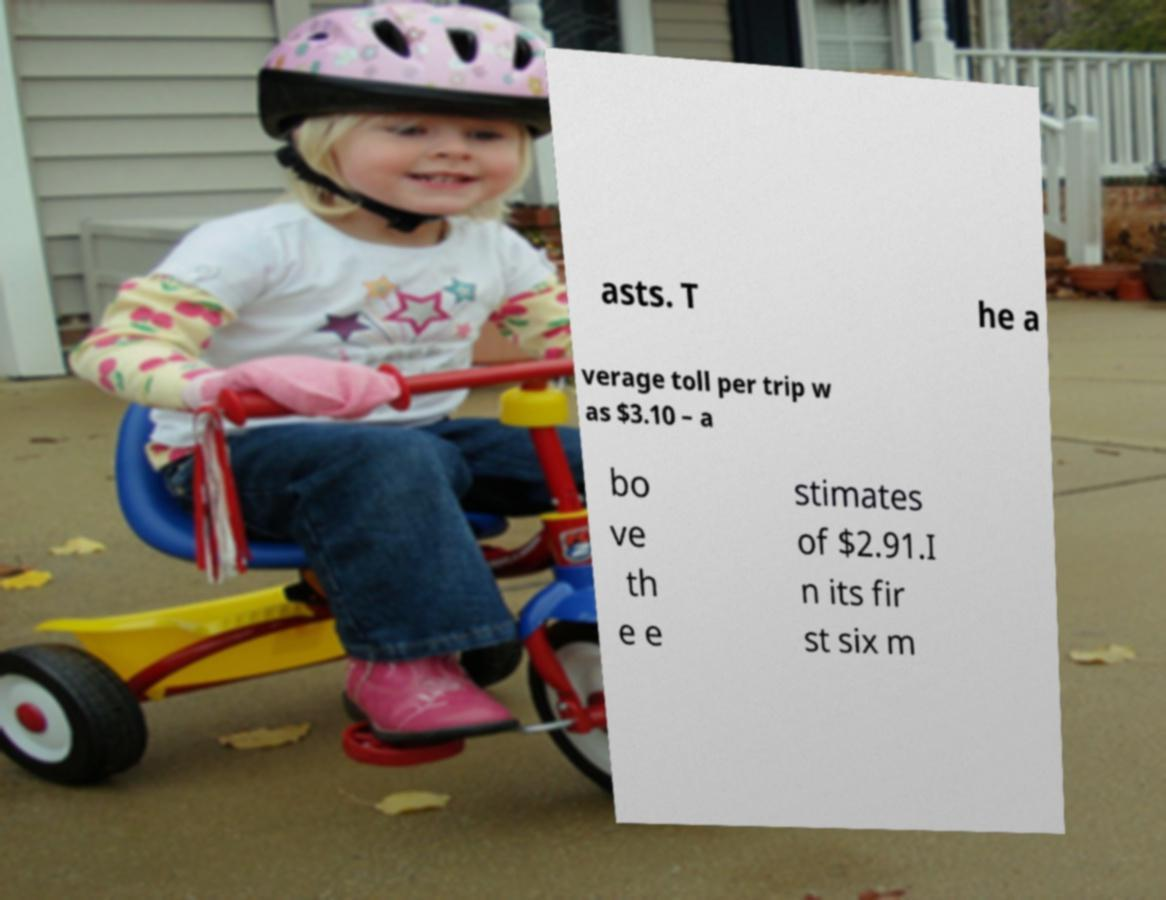Please read and relay the text visible in this image. What does it say? asts. T he a verage toll per trip w as $3.10 – a bo ve th e e stimates of $2.91.I n its fir st six m 